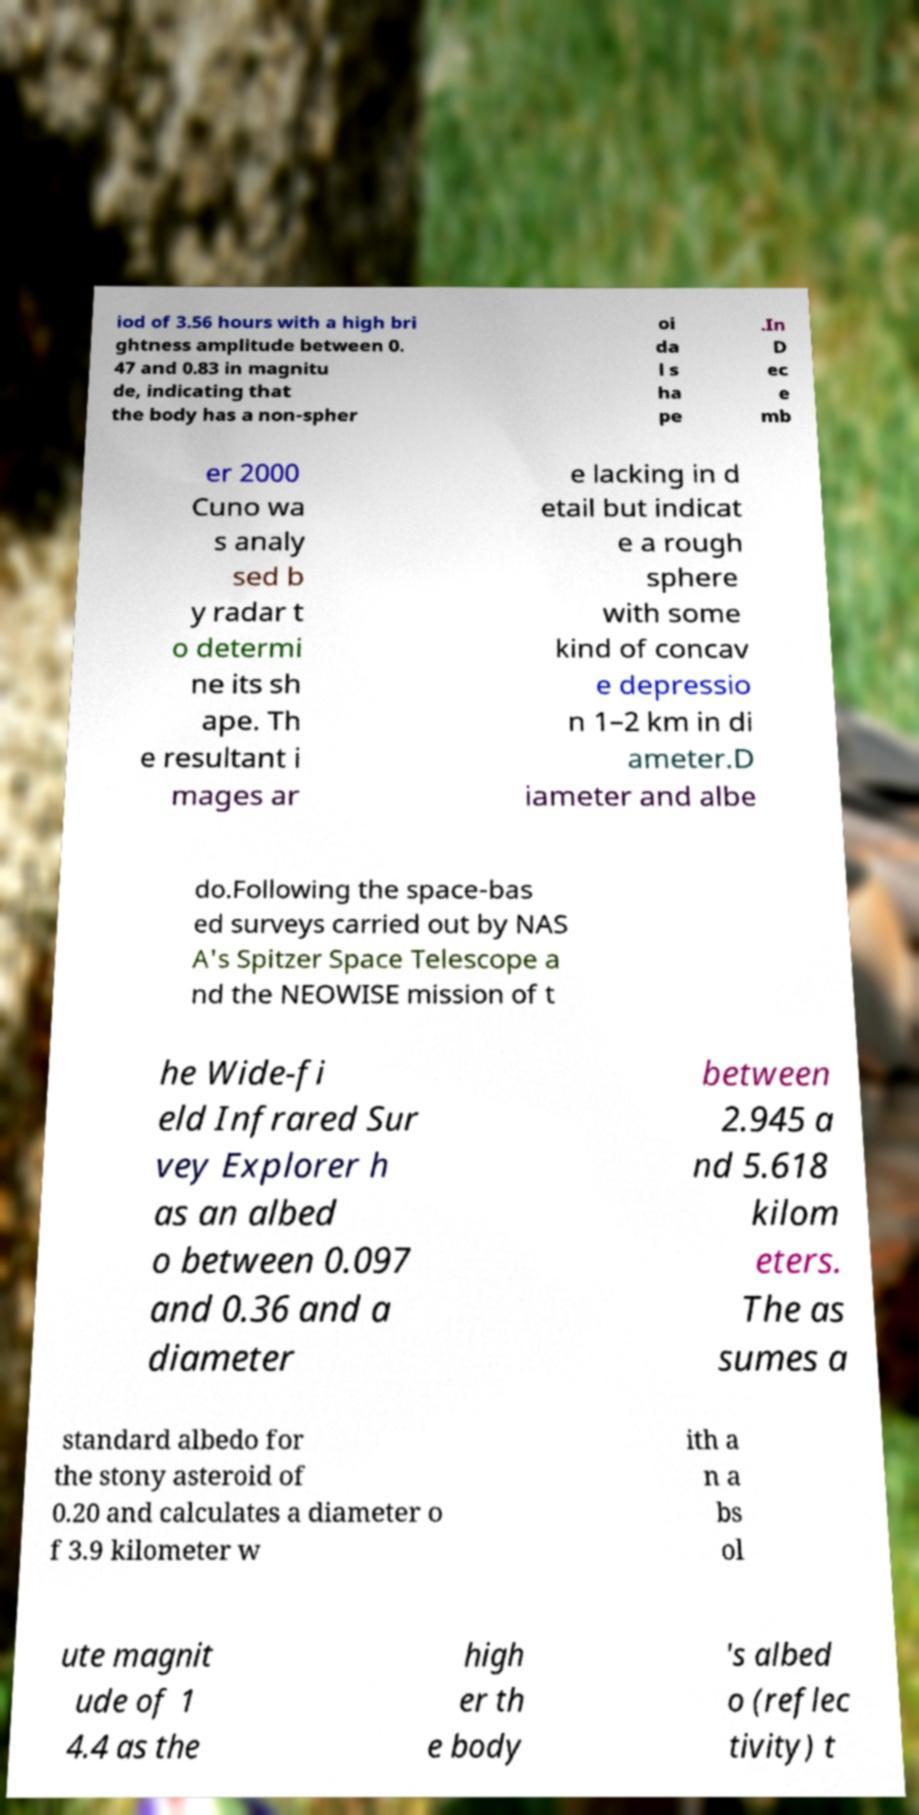For documentation purposes, I need the text within this image transcribed. Could you provide that? iod of 3.56 hours with a high bri ghtness amplitude between 0. 47 and 0.83 in magnitu de, indicating that the body has a non-spher oi da l s ha pe .In D ec e mb er 2000 Cuno wa s analy sed b y radar t o determi ne its sh ape. Th e resultant i mages ar e lacking in d etail but indicat e a rough sphere with some kind of concav e depressio n 1–2 km in di ameter.D iameter and albe do.Following the space-bas ed surveys carried out by NAS A's Spitzer Space Telescope a nd the NEOWISE mission of t he Wide-fi eld Infrared Sur vey Explorer h as an albed o between 0.097 and 0.36 and a diameter between 2.945 a nd 5.618 kilom eters. The as sumes a standard albedo for the stony asteroid of 0.20 and calculates a diameter o f 3.9 kilometer w ith a n a bs ol ute magnit ude of 1 4.4 as the high er th e body 's albed o (reflec tivity) t 